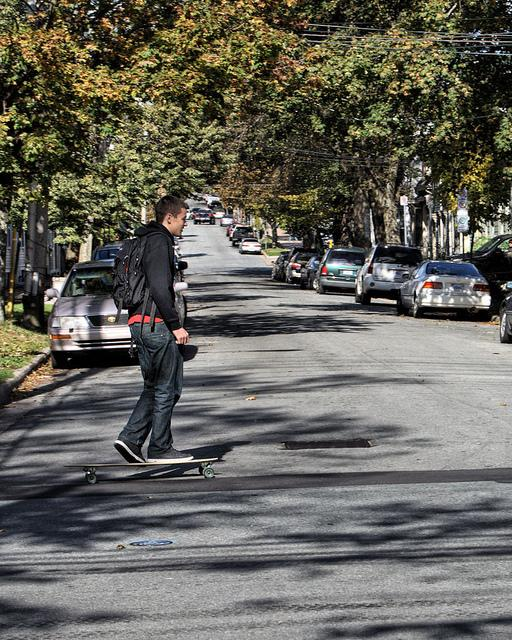What country does the white car originate from? japan 